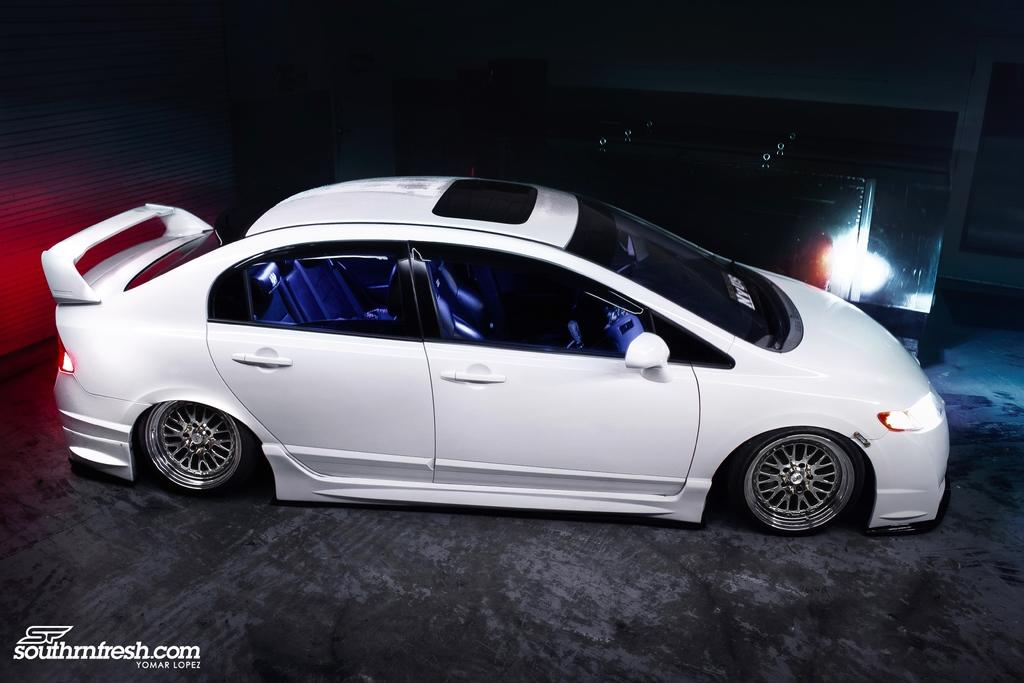What is the main subject of the image? There is a vehicle in the image. Can you describe anything behind the vehicle? Yes, there is an object behind the vehicle in the image. How would you describe the overall lighting in the image? The background of the image is dark. Is there any text visible in the image? Yes, there is some text at the bottom left side of the image. What type of wren can be seen perched on the vehicle in the image? There is no wren present in the image; it only features a vehicle and an object behind it. 